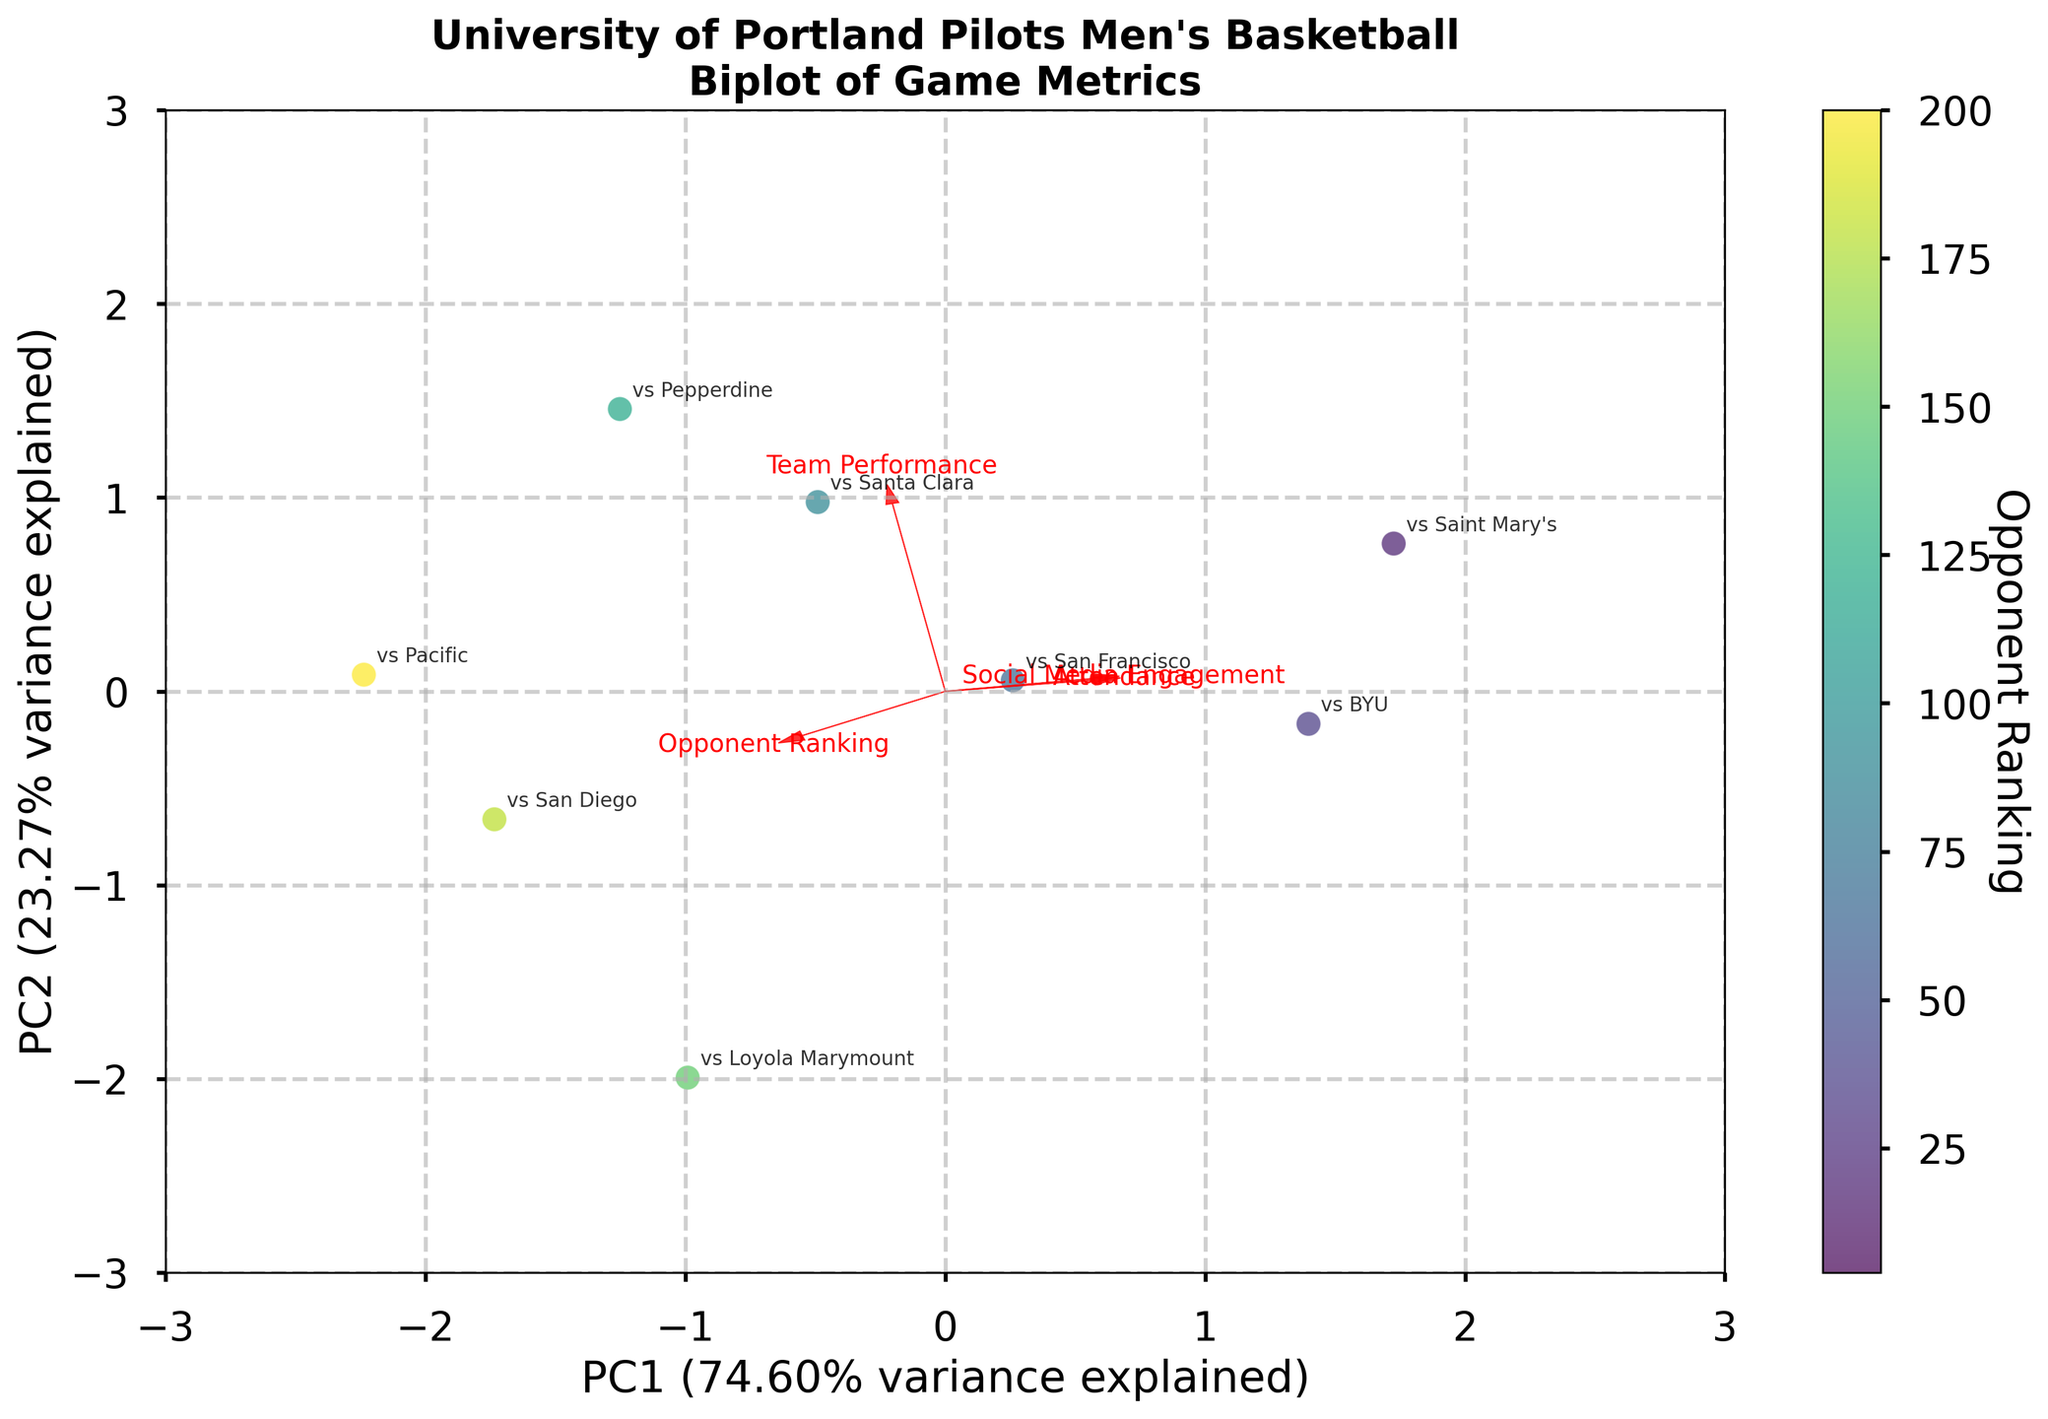How many games are represented in the biplot? Count the number of annotated game labels in the plot. This represents the number of data points, each corresponding to a unique game.
Answer: 9 What is the title of the biplot? Locate the text at the top of the plot, which generally represents the title, summarizing the information displayed.
Answer: University of Portland Pilots Men's Basketball Biplot of Game Metrics Which component (PC1 or PC2) explains more variance? Check the axis labels that display the percentage of variance explained by PC1 and PC2. Compare these percentages to determine which is higher.
Answer: PC1 What color range represents the "Opponent Ranking" in the plot's color bar? Examine the color bar on the side of the plot. Look for the color range used to represent different ranks, which should range from light to dark shades.
Answer: Light to dark shades of green Which game has the highest Opponent Ranking, and how can you tell? Find the game label that corresponds to the lightest shade in the scatter plot, which indicates the highest ranking value according to the color bar.
Answer: vs Gonzaga How do "Attendance" and "Team Performance" relate to each other? Observe the direction of the arrow vectors representing "Attendance" and "Team Performance". Determine if they point in similar or opposite directions to gauge their correlation.
Answer: Positively correlated Which two metrics show the least correlation in the biplot? Identify the pairs of vectors that form the largest angle (close to 90 degrees) with each other, indicating no or weak correlation.
Answer: Attendance and Opponent Ranking Based on the biplot, which game had the lowest attendance and how is it represented? Find the game label closest to the vector endpoint in the direction of decreasing "Attendance" values. Verify using the annotated labels.
Answer: vs Pacific What is the relationship between "Social Media Engagement" and "Opponent Ranking"? Analyze the angle between the vectors for "Social Media Engagement" and "Opponent Ranking". A large angle suggests a negative correlation, while a small angle suggests a positive one.
Answer: Negatively correlated 